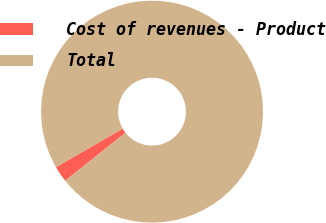Convert chart to OTSL. <chart><loc_0><loc_0><loc_500><loc_500><pie_chart><fcel>Cost of revenues - Product<fcel>Total<nl><fcel>2.36%<fcel>97.64%<nl></chart> 